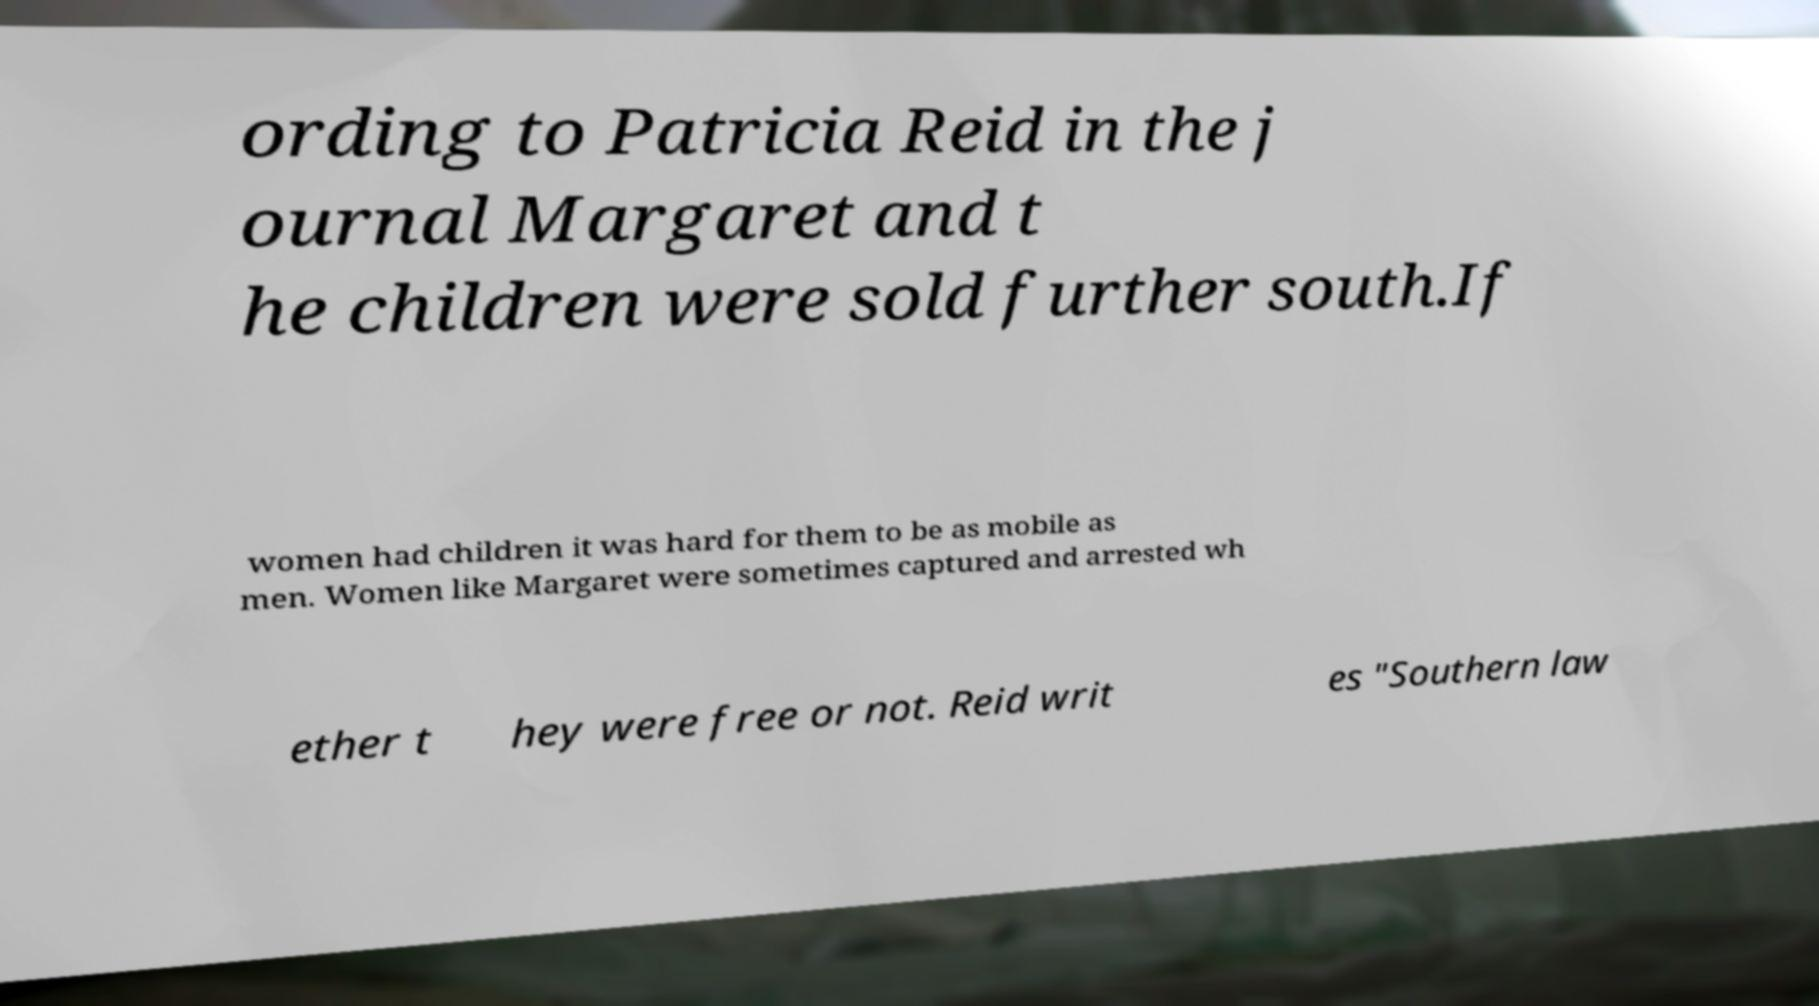For documentation purposes, I need the text within this image transcribed. Could you provide that? ording to Patricia Reid in the j ournal Margaret and t he children were sold further south.If women had children it was hard for them to be as mobile as men. Women like Margaret were sometimes captured and arrested wh ether t hey were free or not. Reid writ es "Southern law 